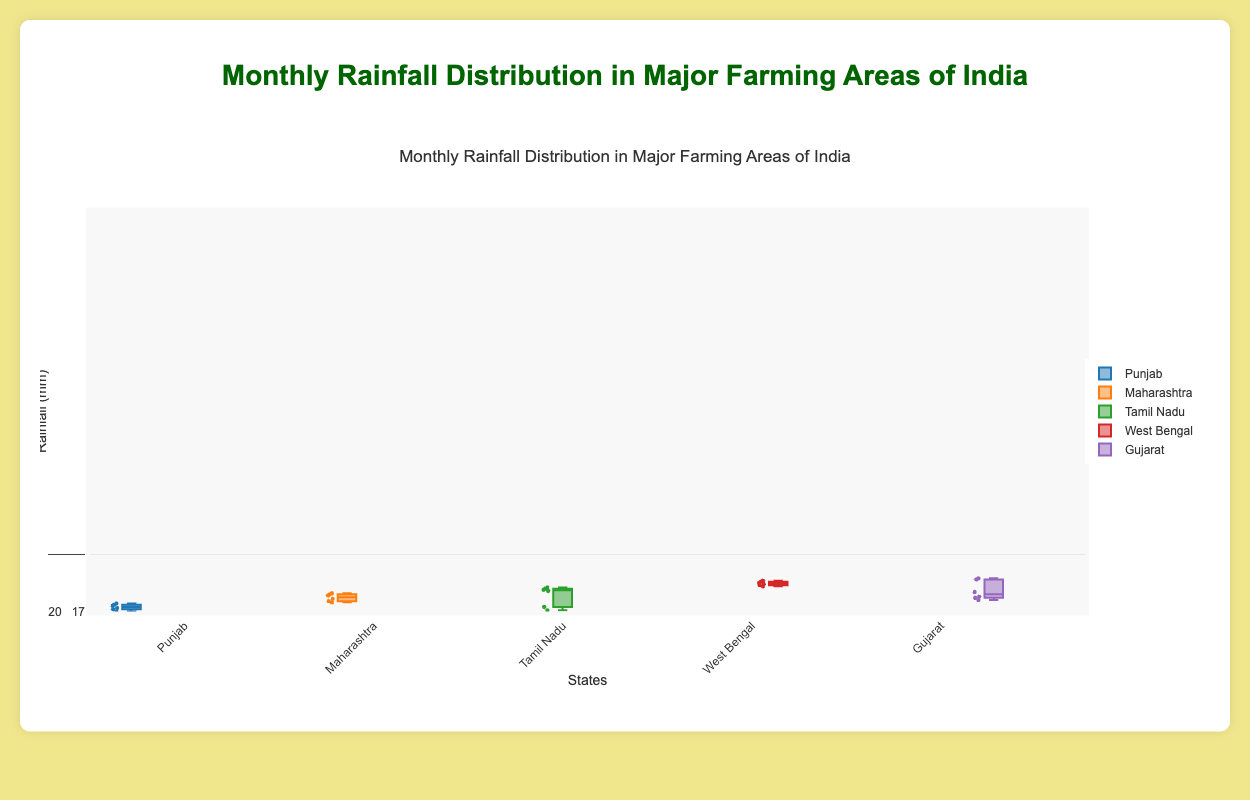What's the title of the figure? The title is usually located at the top of the figure and indicates what the data represents.
Answer: Monthly Rainfall Distribution in Major Farming Areas of India Which state shows the highest median rainfall in July? To find this, look at the median lines inside the boxes for each state for the month of July. The highest median line corresponds to the state with the highest median rainfall.
Answer: Maharashtra What is the range of rainfall in Punjab for the month of July? The range can be found by subtracting the minimum value (bottom whisker) from the maximum value (top whisker) of the Punjab box plot for July.
Answer: 175 mm - 200 mm Which state has the least variability in rainfall in December? Variability is indicated by the length of the box. The state with the shortest box in December has the least variability.
Answer: West Bengal How does the median rainfall in February compare between Tamil Nadu and Gujarat? Compare the median lines (middle lines inside the boxes) of Tamil Nadu and Gujarat for the month of February.
Answer: Tamil Nadu has a higher median rainfall than Gujarat What is the interquartile range (IQR) of rainfall in August for Gujarat? IQR is found by subtracting the lower quartile (bottom of the box) from the upper quartile (top of the box) of the box plot for Gujarat in August.
Answer: 200 mm - 180 mm = 20 mm In which month does Maharashtra receive the maximum observed rainfall? Look for the month where Maharashtra’s box plot has the highest top whisker.
Answer: July Which state has the widest range of monthly rainfall distribution? The widest range is indicated by the length of the whiskers and the box combined across all months.
Answer: Maharashtra How does the median rainfall in March compare between Punjab and West Bengal? Look at the median lines for both Punjab and West Bengal for the month of March and compare their heights.
Answer: West Bengal has a higher median rainfall than Punjab What is the difference between the maximum observed rainfall in July for West Bengal and Gujarat? Find the maximum rainfall value (top whisker) in July for both West Bengal and Gujarat and calculate the difference.
Answer: 340 mm - 300 mm = 40 mm 